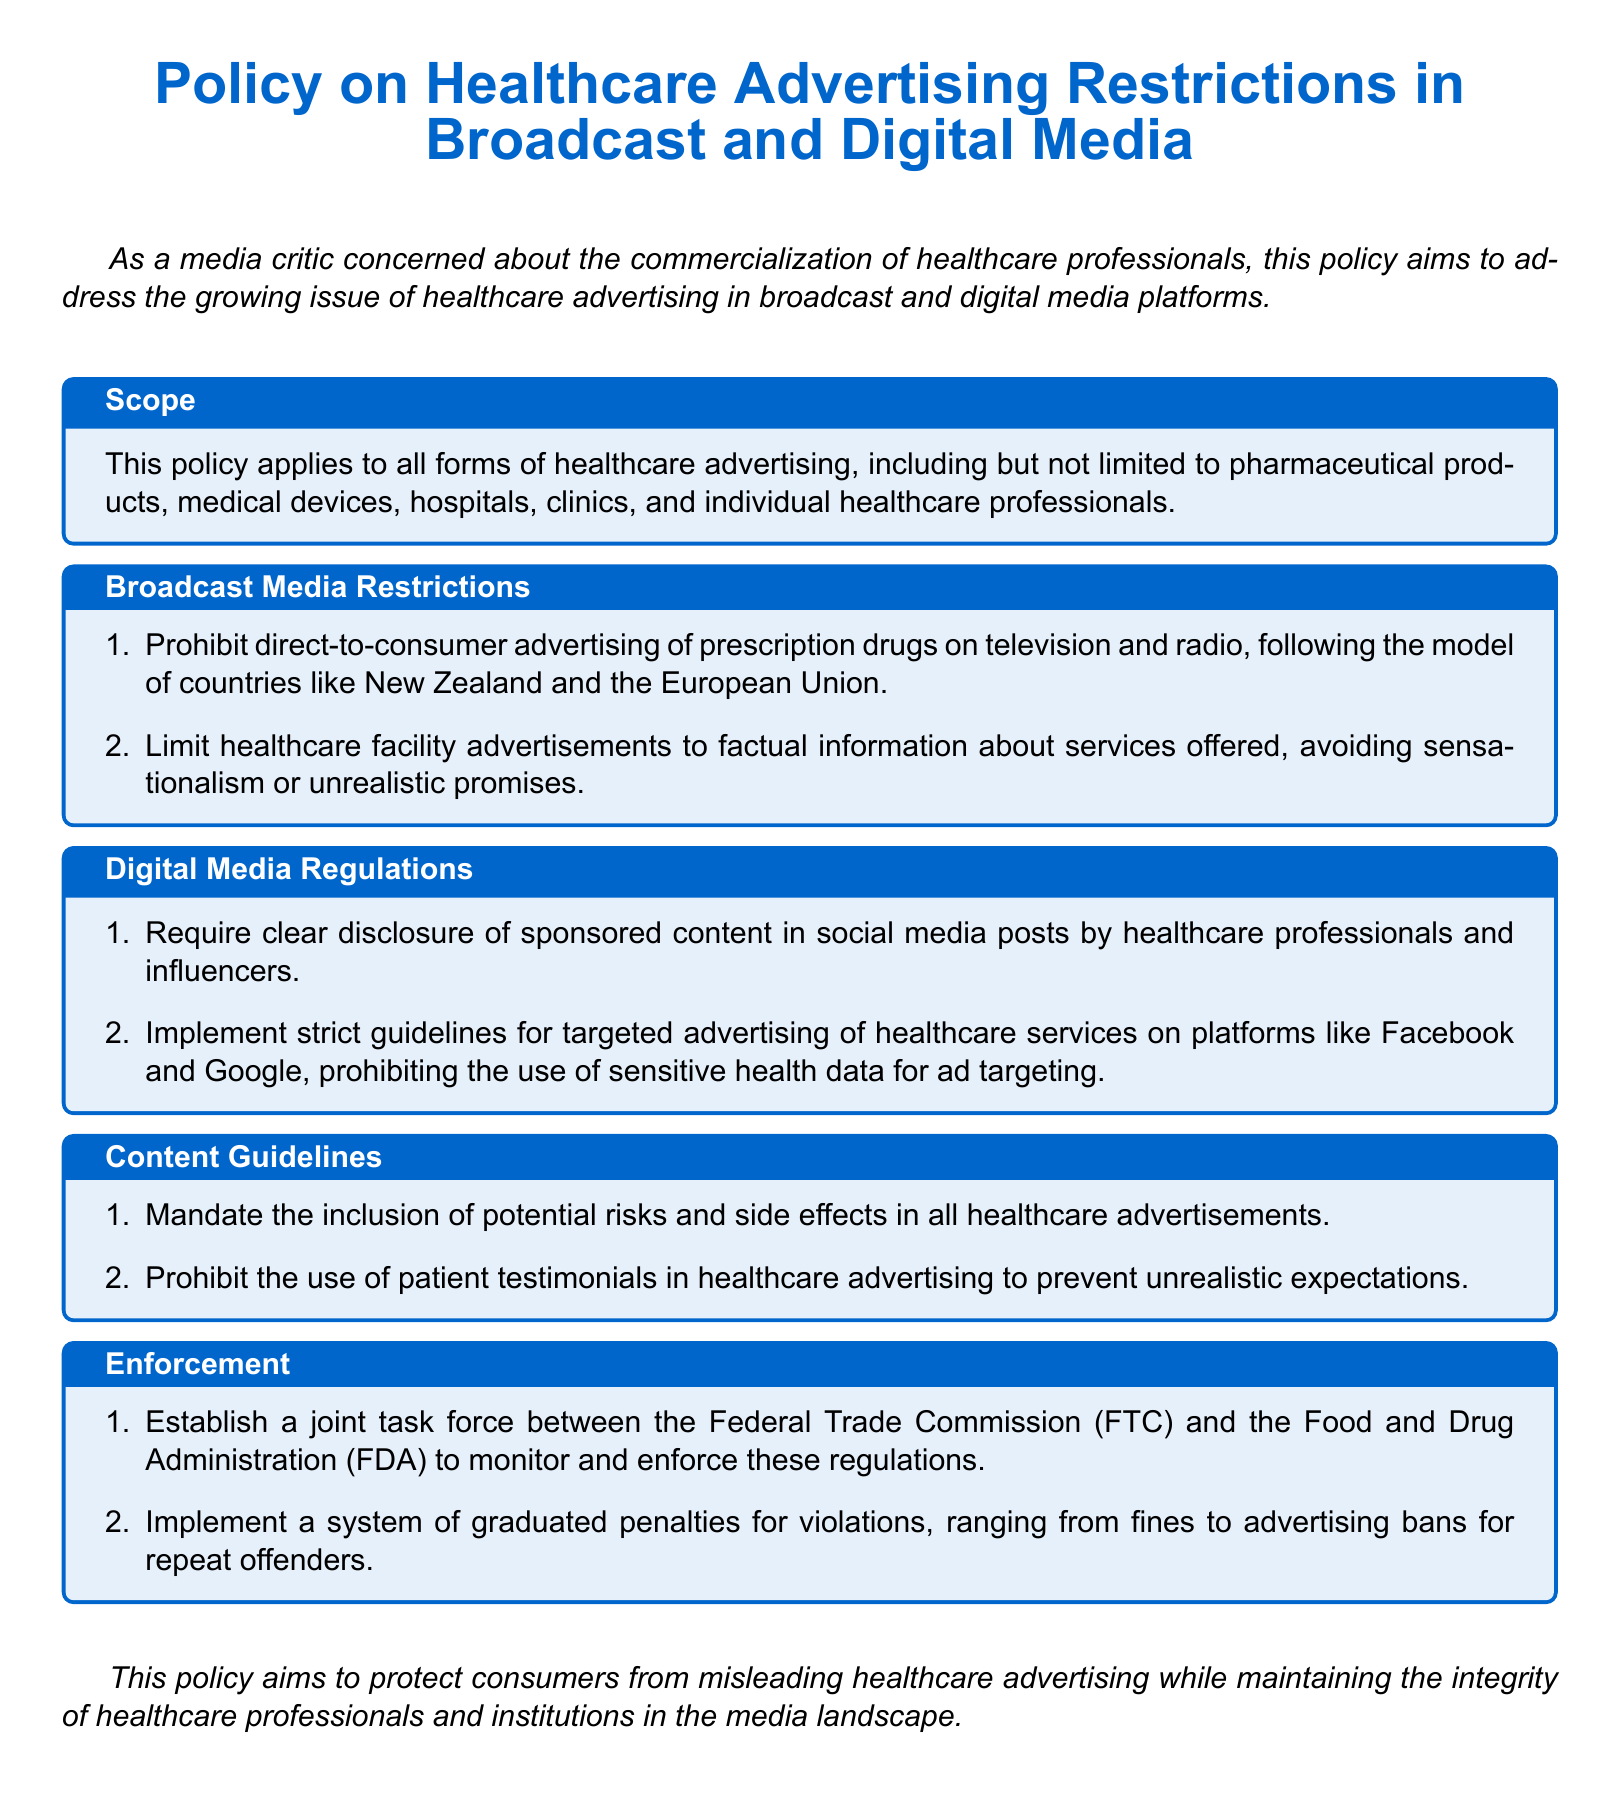What is the title of the document? The title is explicitly stated at the beginning of the document.
Answer: Policy on Healthcare Advertising Restrictions in Broadcast and Digital Media Which organization is involved in enforcement of the policy? The enforcement section mentions the organizations responsible for monitoring and enforcing the regulations.
Answer: Federal Trade Commission (FTC) and Food and Drug Administration (FDA) What type of advertising does the policy prohibit on television and radio? The restrictions section specifies what is not allowed in broadcast media advertising.
Answer: Direct-to-consumer advertising of prescription drugs What is required in social media posts by healthcare professionals? The digital media regulations detail what needs to be disclosed in such posts.
Answer: Clear disclosure of sponsored content How many potential risks and side effects must be included in advertisements? The content guidelines indicate the requirement regarding potential risks.
Answer: All What is the system for violations of the policy? The enforcement section explains the type of penalties for violations.
Answer: Graduated penalties Which type of testimonials are prohibited in healthcare advertising? The content guidelines specify a particular type of testimonial that cannot be used.
Answer: Patient testimonials What must healthcare facility advertisements focus on according to the policy? The broadcast media restrictions clarify the focus of healthcare facility advertisements.
Answer: Factual information about services offered 